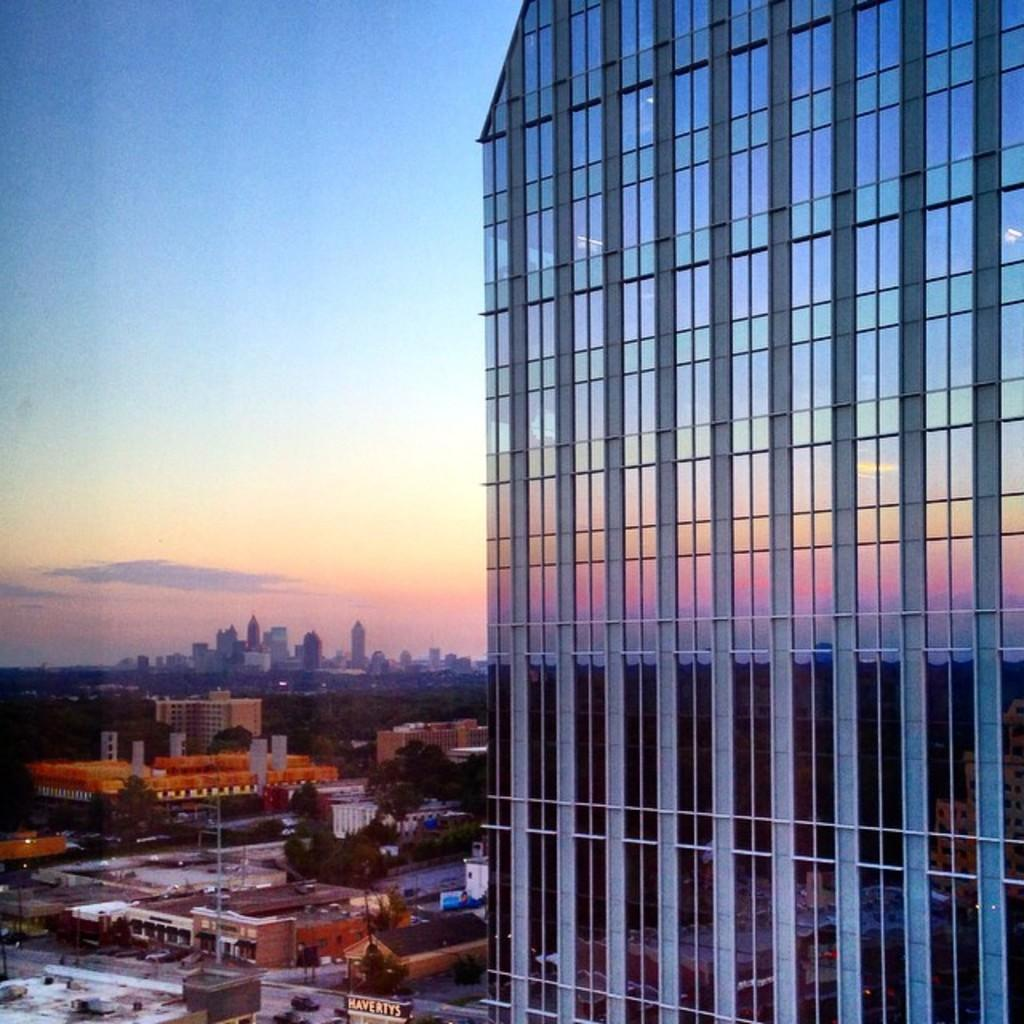What types of structures can be seen in the image? There are buildings, houses, and skyscrapers in the image. What natural elements are present in the image? There are trees in the image. What is the purpose of the pole in the image? The purpose of the pole is not specified in the image, but it could be for signage, lighting, or other utilities. What is visible in the background of the image? The sky is visible in the image. What degree of temperature is being experienced by the trees in the image? The image does not provide information about the temperature, so it cannot be determined how the trees are experiencing any specific degree of temperature. 